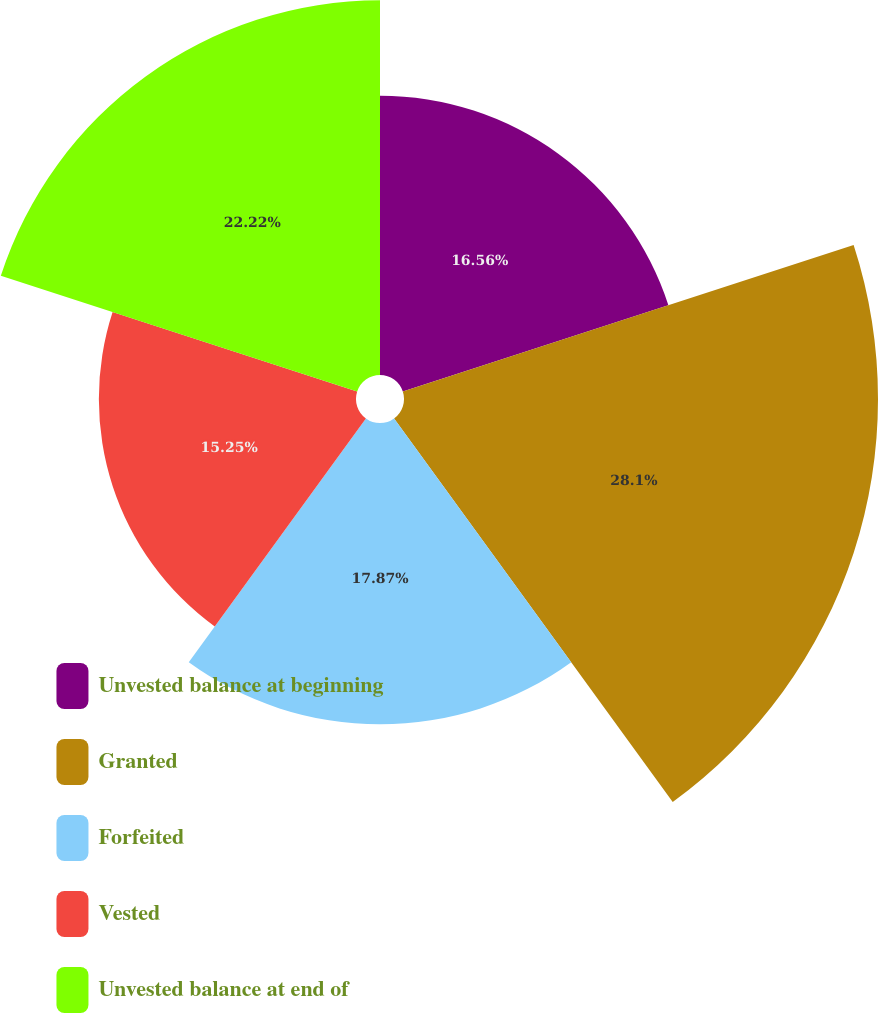Convert chart to OTSL. <chart><loc_0><loc_0><loc_500><loc_500><pie_chart><fcel>Unvested balance at beginning<fcel>Granted<fcel>Forfeited<fcel>Vested<fcel>Unvested balance at end of<nl><fcel>16.56%<fcel>28.11%<fcel>17.87%<fcel>15.25%<fcel>22.22%<nl></chart> 